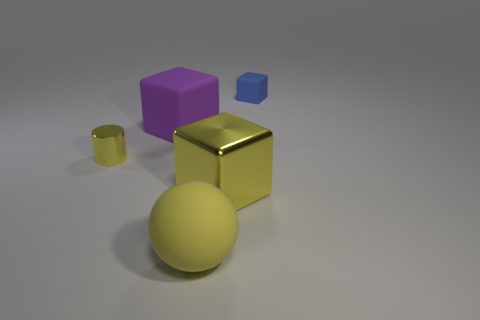Is the color of the big rubber object that is to the right of the big purple rubber thing the same as the tiny metallic cylinder?
Provide a succinct answer. Yes. Is the size of the purple rubber cube the same as the blue rubber block?
Your answer should be very brief. No. What shape is the other thing that is the same size as the blue matte thing?
Make the answer very short. Cylinder. Is the size of the matte object in front of the shiny cylinder the same as the shiny cylinder?
Offer a terse response. No. There is a purple object that is the same size as the ball; what is it made of?
Ensure brevity in your answer.  Rubber. Is there a metallic cylinder that is to the left of the big rubber object in front of the big cube behind the shiny cube?
Ensure brevity in your answer.  Yes. Is there anything else that has the same shape as the large yellow shiny object?
Give a very brief answer. Yes. There is a shiny object that is right of the sphere; does it have the same color as the tiny thing that is left of the blue block?
Ensure brevity in your answer.  Yes. Are any tiny purple things visible?
Ensure brevity in your answer.  No. There is a big block that is the same color as the cylinder; what is its material?
Your answer should be compact. Metal. 